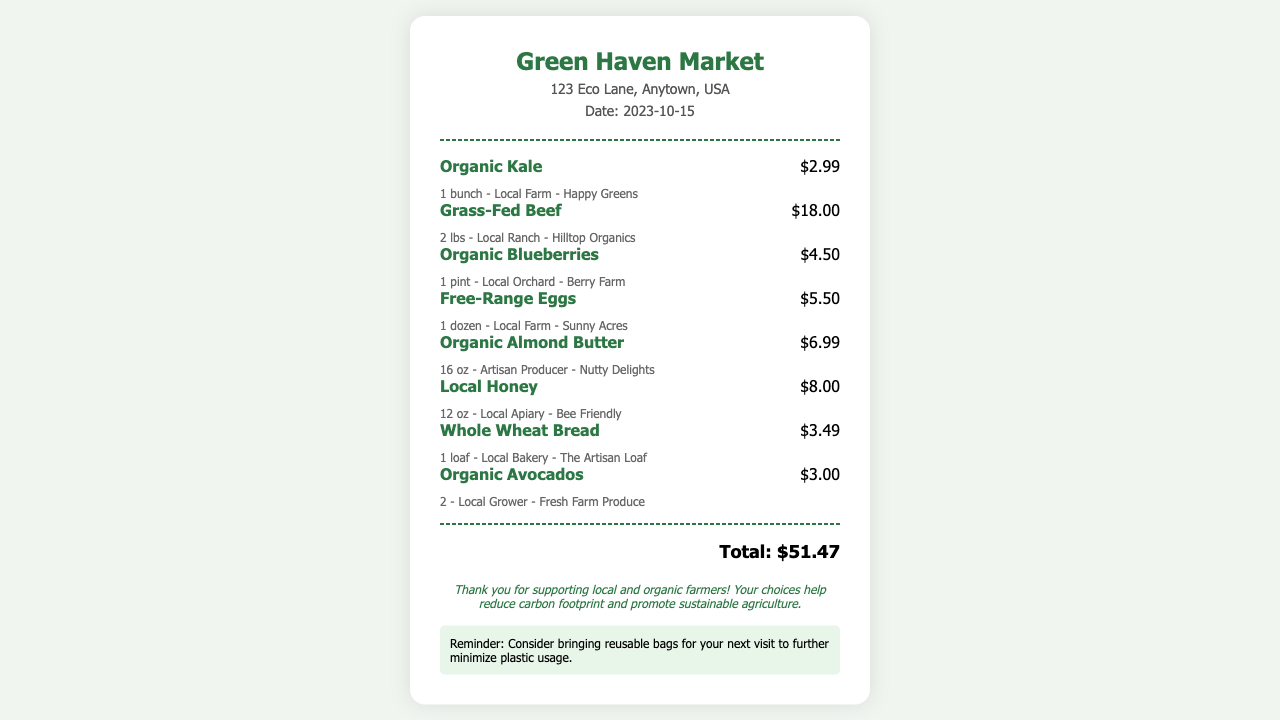What is the store name? The store name is clearly displayed at the top of the receipt.
Answer: Green Haven Market What date is on the receipt? The receipt includes the date of the purchase.
Answer: 2023-10-15 How much did the Organic Kale cost? The price of the Organic Kale is indicated next to the item.
Answer: $2.99 What is the total amount spent? The total is summarized at the bottom of the receipt.
Answer: $51.47 How many pounds of Grass-Fed Beef were purchased? The quantity of Grass-Fed Beef is noted in the item description.
Answer: 2 lbs Which local farm produces the Free-Range Eggs? The local farm is specified in the details of the Free-Range Eggs.
Answer: Sunny Acres What type of bread is listed on the receipt? The type of bread is denoted in the item name on the receipt.
Answer: Whole Wheat Bread What is a reminder provided on the receipt? The receipt includes a section with a reminder message for the customer.
Answer: Consider bringing reusable bags 